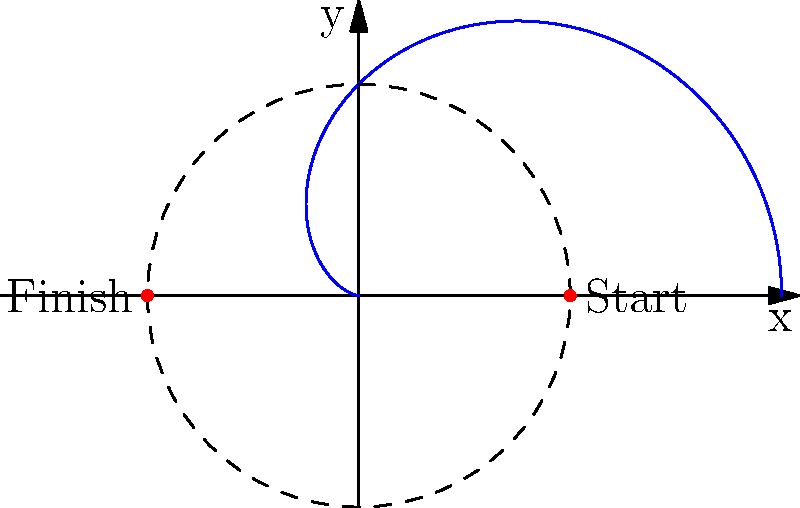As an amateur skier looking to improve your performance, you're studying optimal ski trajectories. Consider a ski slope represented in polar coordinates by the equation $r = 5(1 + \cos\theta)$, where $r$ is in meters. If you start at the point $(5,0)$ and finish at $(-5,0)$, what is the total distance of your ski path in meters? Let's approach this step-by-step:

1) The curve $r = 5(1 + \cos\theta)$ is known as a cardioid.

2) To find the length of the curve, we need to use the arc length formula in polar coordinates:

   $L = \int_{\theta_1}^{\theta_2} \sqrt{r^2 + \left(\frac{dr}{d\theta}\right)^2} d\theta$

3) We need to find $\frac{dr}{d\theta}$:
   $\frac{dr}{d\theta} = -5\sin\theta$

4) Substituting into the arc length formula:

   $L = \int_{0}^{\pi} \sqrt{(5(1+\cos\theta))^2 + (-5\sin\theta)^2} d\theta$

5) Simplifying under the square root:

   $L = \int_{0}^{\pi} \sqrt{25(1+\cos\theta)^2 + 25\sin^2\theta} d\theta$
   
   $L = 5\int_{0}^{\pi} \sqrt{(1+\cos\theta)^2 + \sin^2\theta} d\theta$

6) Using the trigonometric identity $\sin^2\theta + \cos^2\theta = 1$, we can simplify further:

   $L = 5\int_{0}^{\pi} \sqrt{1 + 2\cos\theta + \cos^2\theta + \sin^2\theta} d\theta$
   
   $L = 5\int_{0}^{\pi} \sqrt{2 + 2\cos\theta} d\theta$
   
   $L = 5\int_{0}^{\pi} \sqrt{2(1 + \cos\theta)} d\theta$
   
   $L = 5\sqrt{2}\int_{0}^{\pi} \sqrt{1 + \cos\theta} d\theta$

7) This integral evaluates to:

   $L = 5\sqrt{2} \cdot 2 = 10\sqrt{2}$ meters

Therefore, the total distance of your ski path is $10\sqrt{2}$ meters.
Answer: $10\sqrt{2}$ meters 